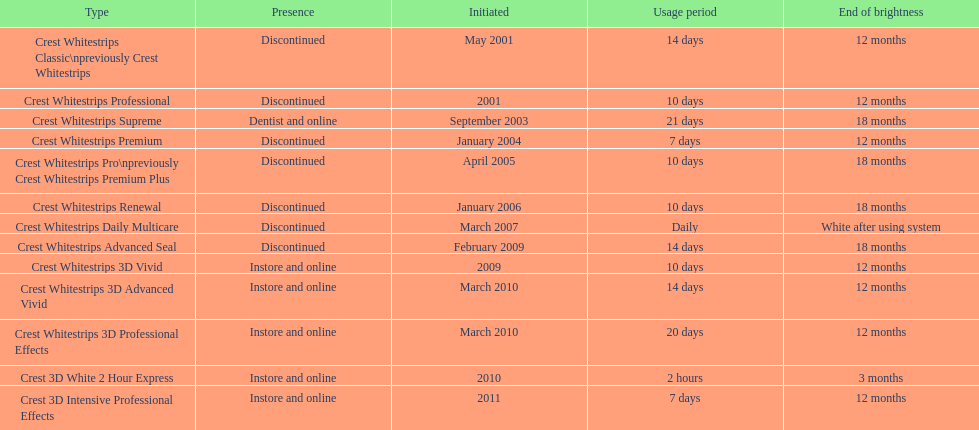Which model has the highest 'length of use' to 'last of whiteness' ratio? Crest Whitestrips Supreme. 